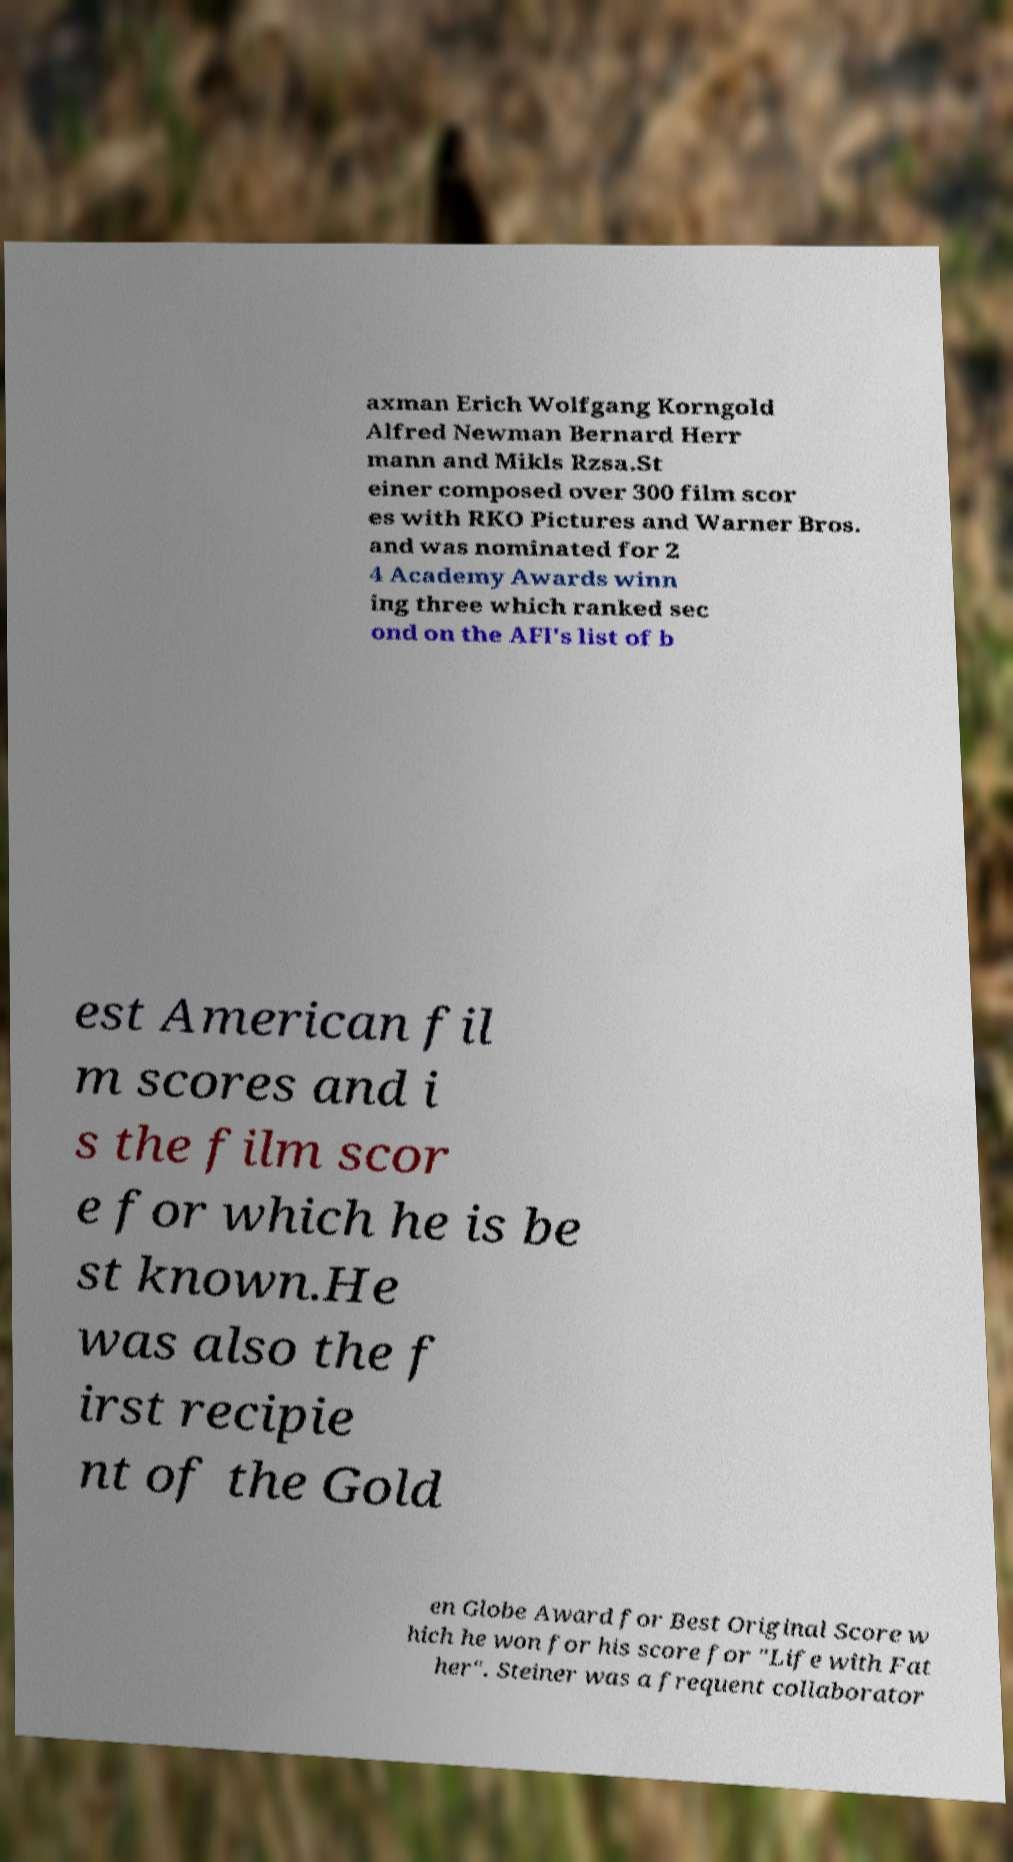Can you read and provide the text displayed in the image?This photo seems to have some interesting text. Can you extract and type it out for me? axman Erich Wolfgang Korngold Alfred Newman Bernard Herr mann and Mikls Rzsa.St einer composed over 300 film scor es with RKO Pictures and Warner Bros. and was nominated for 2 4 Academy Awards winn ing three which ranked sec ond on the AFI's list of b est American fil m scores and i s the film scor e for which he is be st known.He was also the f irst recipie nt of the Gold en Globe Award for Best Original Score w hich he won for his score for "Life with Fat her". Steiner was a frequent collaborator 